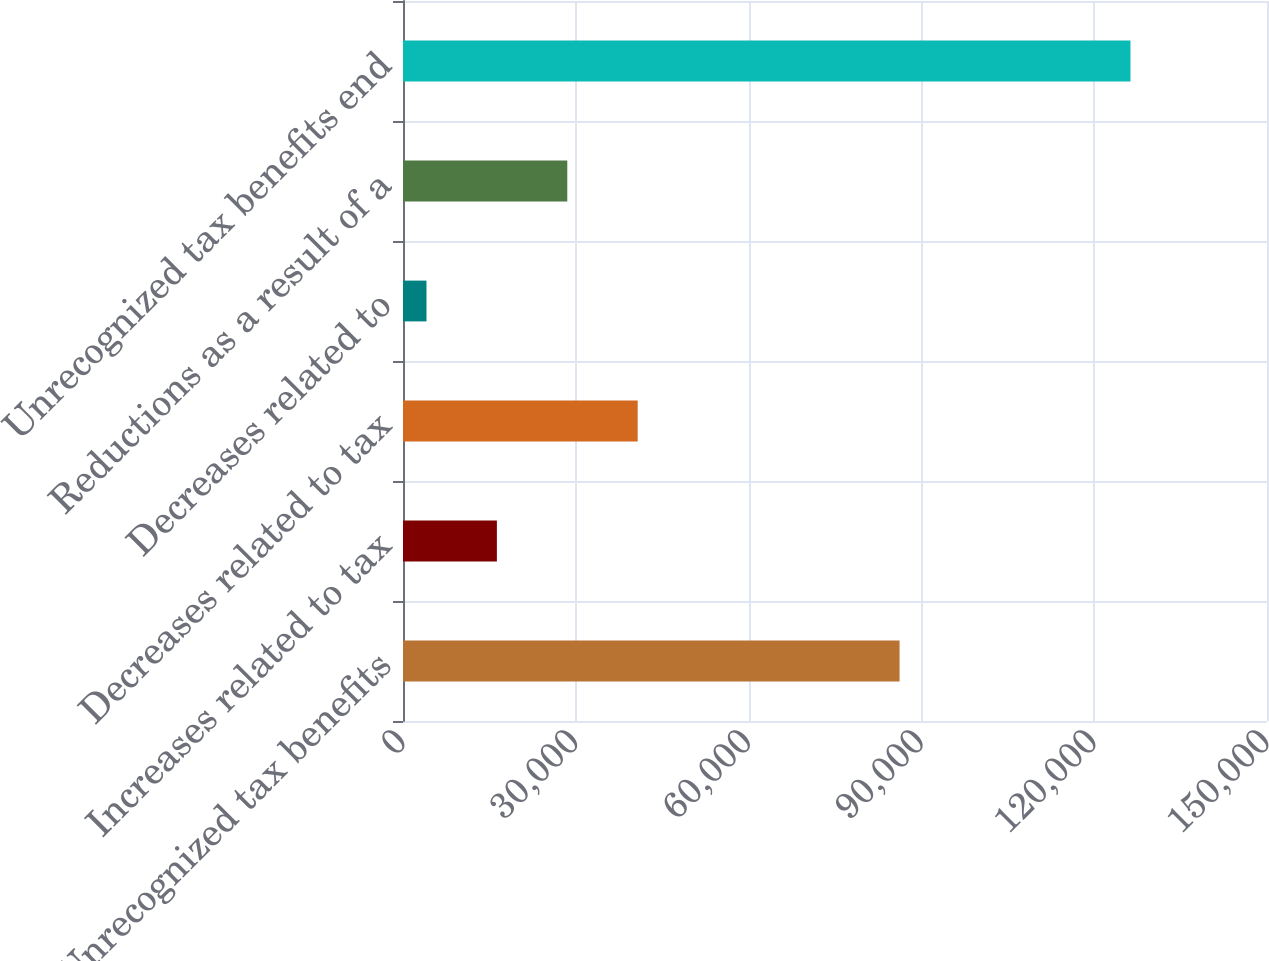Convert chart to OTSL. <chart><loc_0><loc_0><loc_500><loc_500><bar_chart><fcel>Unrecognized tax benefits<fcel>Increases related to tax<fcel>Decreases related to tax<fcel>Decreases related to<fcel>Reductions as a result of a<fcel>Unrecognized tax benefits end<nl><fcel>86209<fcel>16300.1<fcel>40744.3<fcel>4078<fcel>28522.2<fcel>126299<nl></chart> 